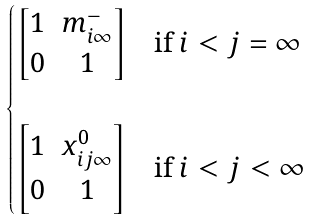<formula> <loc_0><loc_0><loc_500><loc_500>\begin{cases} \left [ \begin{matrix} 1 & m ^ { - } _ { i \infty } \\ 0 & 1 \end{matrix} \right ] & \text {if $i<j=\infty$} \\ & \\ \left [ \begin{matrix} 1 & x ^ { 0 } _ { i j \infty } \\ 0 & 1 \end{matrix} \right ] & \text {if $i<j<\infty$} \end{cases}</formula> 